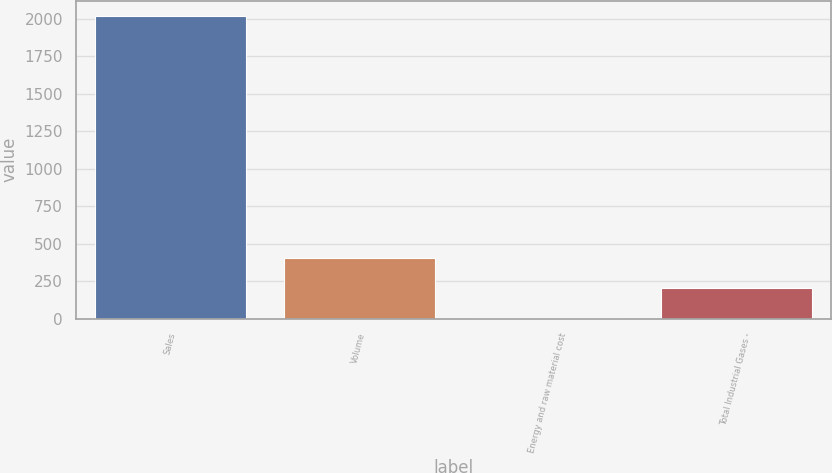<chart> <loc_0><loc_0><loc_500><loc_500><bar_chart><fcel>Sales<fcel>Volume<fcel>Energy and raw material cost<fcel>Total Industrial Gases -<nl><fcel>2018<fcel>404.4<fcel>1<fcel>202.7<nl></chart> 